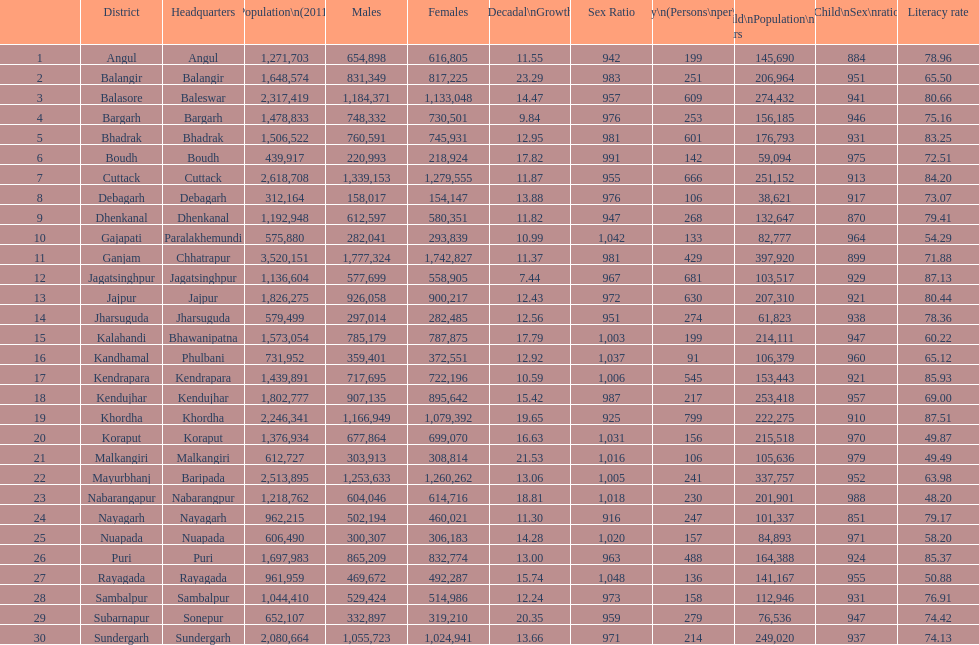What city is last in literacy? Nabarangapur. 